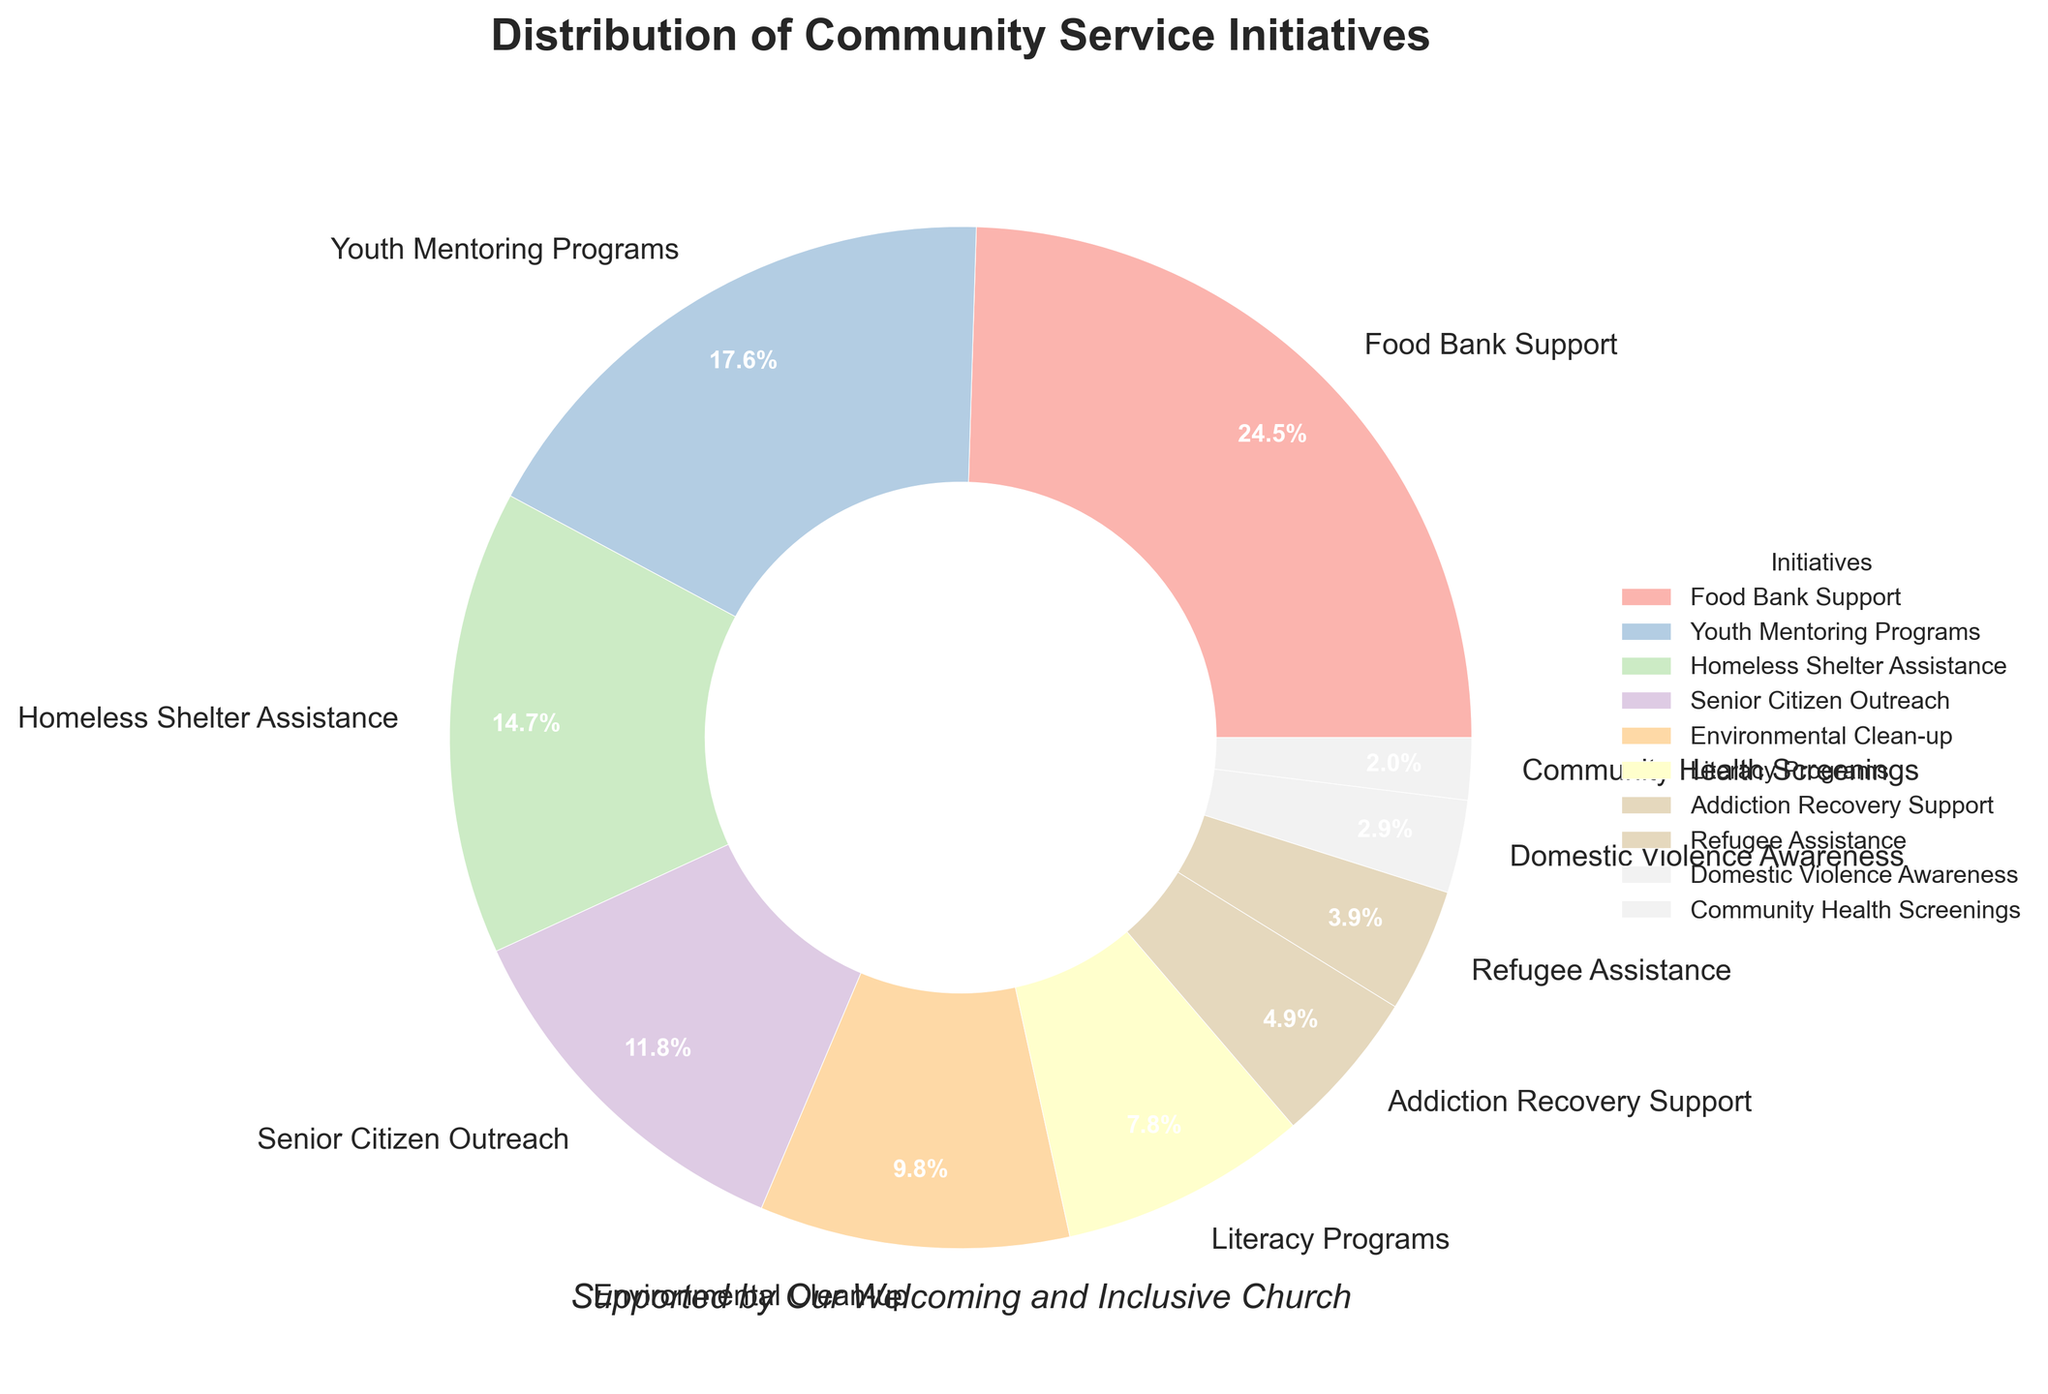What is the percentage of support given to the Food Bank? According to the legend and the pie chart, the segment labeled "Food Bank Support" accounts for 25% of the total support initiatives.
Answer: 25% Which initiative receives the least amount of support? By observing the labels and percentages on the pie chart, "Community Health Screenings" is represented with 2%, which is the smallest percentage shown.
Answer: Community Health Screenings How much support is provided to the Youth Mentoring Programs and Literacy Programs combined? Summing up the percentages for "Youth Mentoring Programs" (18%) and "Literacy Programs" (8%) gives 18 + 8 = 26%.
Answer: 26% Which initiative receives more support: Environmental Clean-up or Senior Citizen Outreach? "Environmental Clean-up" is supported with 10%, while "Senior Citizen Outreach" receives 12% support. Comparing these, "Senior Citizen Outreach" receives more support.
Answer: Senior Citizen Outreach What proportion of the support initiatives is directed towards Addiction Recovery Support, Refugee Assistance, and Domestic Violence Awareness combined? By summing the percentages for "Addiction Recovery Support" (5%), "Refugee Assistance" (4%), and "Domestic Violence Awareness" (3%), we get 5 + 4 + 3 = 12%.
Answer: 12% Is the support for the Homeless Shelter Assistance greater than, less than, or equal to the support for Youth Mentoring Programs? The percentage for "Homeless Shelter Assistance" is 15%, while "Youth Mentoring Programs" is supported with 18%. Therefore, the support for "Homeless Shelter Assistance" is less than that for "Youth Mentoring Programs".
Answer: Less than Which colored segment represents the Environmental Clean-up initiative? By matching the label "Environmental Clean-up" to its corresponding segment in the pie chart and identifying the color from the palette used (likely a shade from the Pastel1 colormap), we can determine the specific color, typically a soft shade of green, blue, or pink. Specific color identification requires referring directly to the visual.
Answer: Depends on the specific visual How does the combined support for Homeless Shelter Assistance and Environmental Clean-up compare to support for Food Bank Support? Summing the percentages for "Homeless Shelter Assistance" (15%) and "Environmental Clean-up" (10%) results in 15 + 10 = 25%, which is the same as the support for "Food Bank Support" at 25%.
Answer: Equal Which two initiatives have combined support equal to that of Food Bank Support? The two initiatives are "Homeless Shelter Assistance" (15%) and "Environmental Clean-up" (10%). Their combined support is 15 + 10 = 25%, equal to the "Food Bank Support" percentage of 25%.
Answer: Homeless Shelter Assistance and Environmental Clean-up 